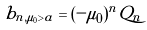Convert formula to latex. <formula><loc_0><loc_0><loc_500><loc_500>b _ { n , \mu _ { 0 } > a } = ( - \mu _ { 0 } ) ^ { n } Q _ { n }</formula> 